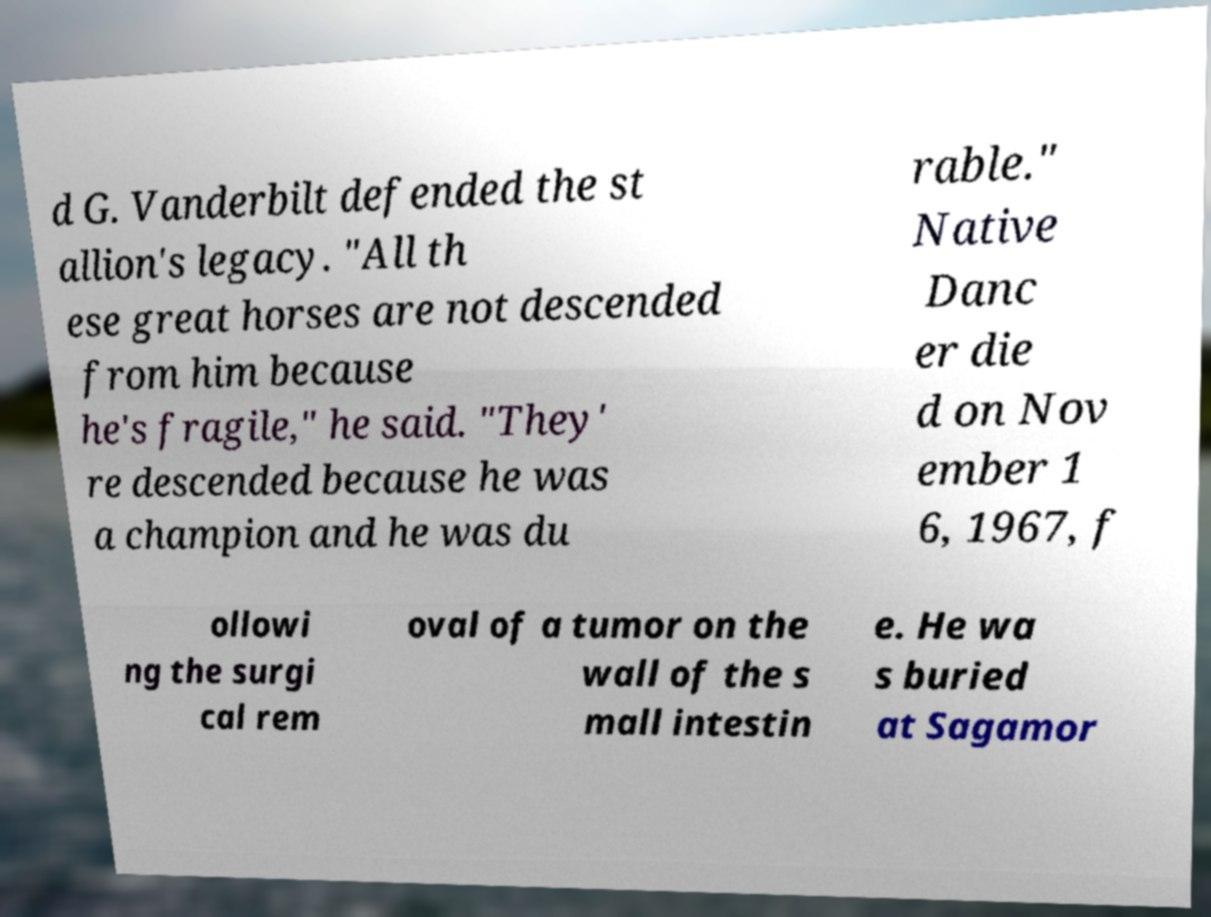What messages or text are displayed in this image? I need them in a readable, typed format. d G. Vanderbilt defended the st allion's legacy. "All th ese great horses are not descended from him because he's fragile," he said. "They' re descended because he was a champion and he was du rable." Native Danc er die d on Nov ember 1 6, 1967, f ollowi ng the surgi cal rem oval of a tumor on the wall of the s mall intestin e. He wa s buried at Sagamor 